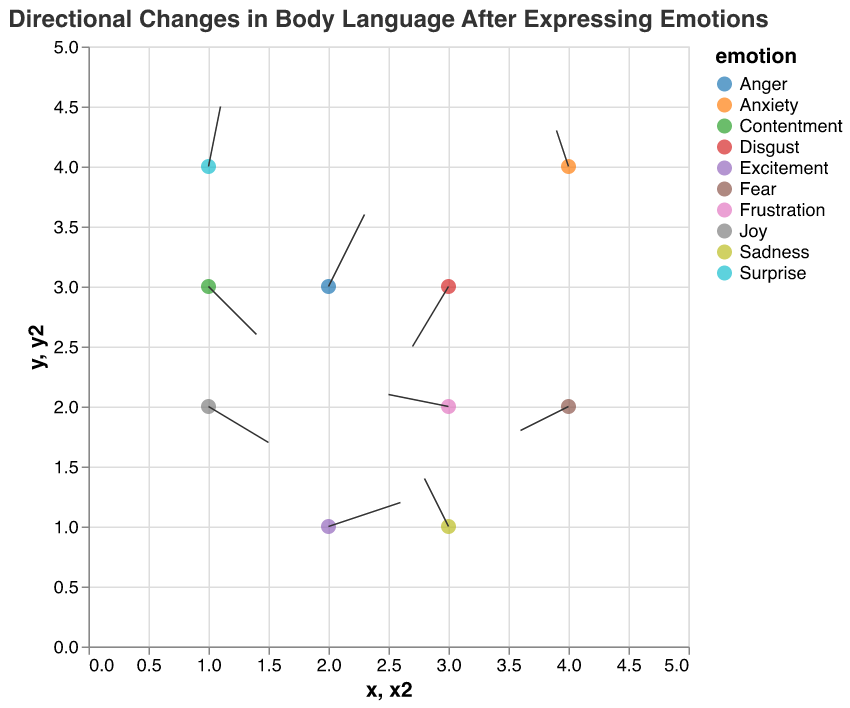What is the title of the quiver plot? The title is usually positioned at the top of the plot and summarizes what the plot is about. Here, the title is "Directional Changes in Body Language After Expressing Emotions".
Answer: Directional Changes in Body Language After Expressing Emotions How many emotions are represented in the plot? Each emotion is indicated by a unique color. By counting the number of unique colors associated with each point, we can determine the number of different emotions. There are 10 unique emotions.
Answer: 10 Which emotion shows the largest movement in the x-direction? To find this, we need to look at the value of 'u' for each data point and identify the one with the largest absolute value. The largest movement in the x-direction is for "Frustration" with a value of -0.5.
Answer: Frustration Which emotion shows a movement in the negative y-direction? To determine this, we need to identify the emotions associated with negative 'v' values. Emotions with negative y-direction movements are "Joy", "Disgust", and "Contentment".
Answer: Joy, Disgust, Contentment What are the start and end coordinates for the emotion "Fear"? The starting coordinates are given by (x, y) and the end coordinates can be calculated by adding (u, v) to (x, y). For "Fear", the start is (4,2) and end is calculated as (4+(-0.4),2+(-0.2)) = (3.6,1.8).
Answer: Start: (4,2), End: (3.6,1.8) Which emotion has the smallest change in its position? The smallest change in position can be found by calculating the magnitude of the movement vector (u, v) for each emotion. The magnitude is sqrt(u^2 + v^2). Here, the smallest magnitude corresponds to "Anxiety" with a magnitude of sqrt((-0.1)^2 + (0.3)^2) = sqrt(0.01 + 0.09) = sqrt(0.1) ≈ 0.32.
Answer: Anxiety How many emotions show a positive change in the y-direction? We need to count the number of data points where the 'v' component is positive. Emotions with positive y-direction changes are "Sadness", "Anger", "Surprise", "Excitement", and "Anxiety". There are 5 such emotions.
Answer: 5 What is the average horizontal movement for all emotions? The average horizontal movement can be determined by summing all 'u' values and dividing by the number of data points. Sum of all 'u' values: 0.5 - 0.2 + 0.3 - 0.4 + 0.1 - 0.3 + 0.6 - 0.1 + 0.4 - 0.5 = 0.4. Number of data points is 10. Therefore, average = 0.4 / 10 = 0.04.
Answer: 0.04 Which two emotions have the most similar movement vectors? To find this, we need to compare the (u, v) pairs for each emotion and calculate their Euclidean distance. The two emotions with the smallest distance are "Contentment" (0.4, -0.4) and "Joy" (0.5, -0.3). The distance is sqrt((0.5-0.4)^2 + (-0.3-(-0.4))^2) = sqrt(0.01 + 0.01) = sqrt(0.02) ≈ 0.14.
Answer: Joy and Contentment What is the direction of the movement for "Excitement"? The direction can be described using the vector components (u, v). For "Excitement" with a (u, v) of (0.6, 0.2), the movement is positively skewed in both x and y directions.
Answer: Positive x and y 